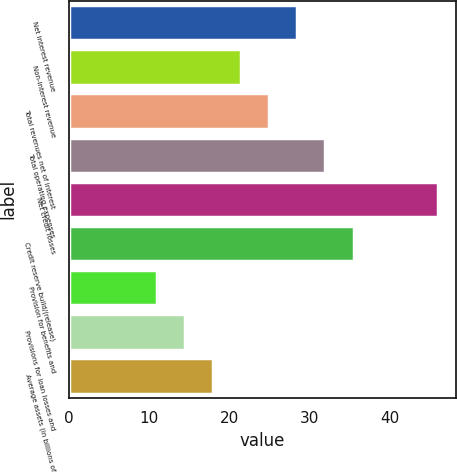<chart> <loc_0><loc_0><loc_500><loc_500><bar_chart><fcel>Net interest revenue<fcel>Non-interest revenue<fcel>Total revenues net of interest<fcel>Total operating expenses<fcel>Net credit losses<fcel>Credit reserve build/(release)<fcel>Provision for benefits and<fcel>Provisions for loan losses and<fcel>Average assets (in billions of<nl><fcel>28.5<fcel>21.5<fcel>25<fcel>32<fcel>46<fcel>35.5<fcel>11<fcel>14.5<fcel>18<nl></chart> 